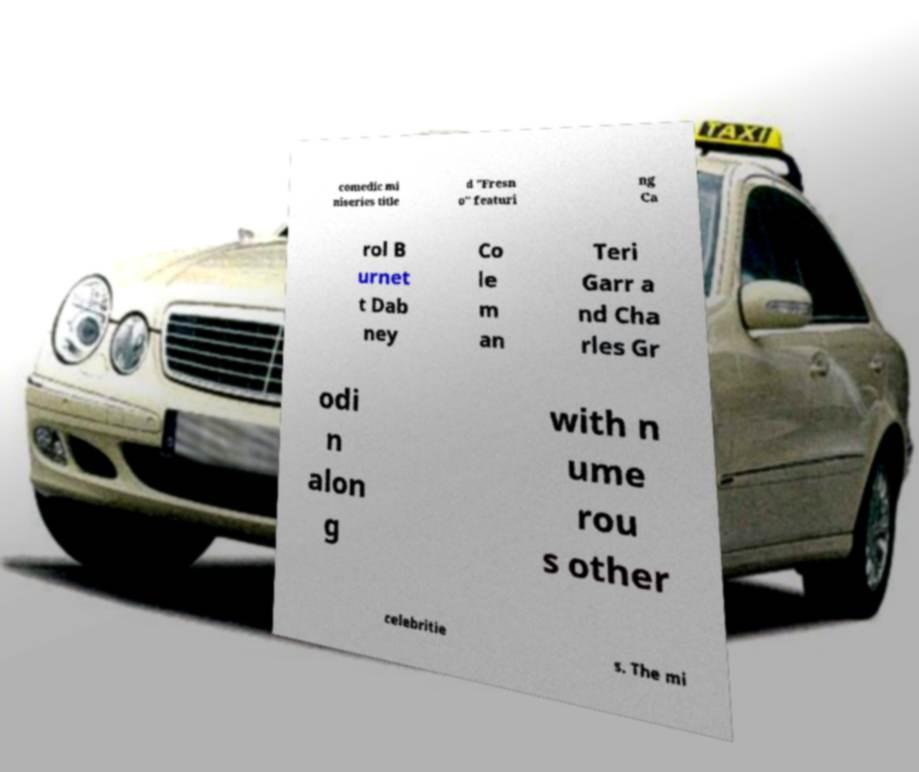Could you assist in decoding the text presented in this image and type it out clearly? comedic mi niseries title d "Fresn o" featuri ng Ca rol B urnet t Dab ney Co le m an Teri Garr a nd Cha rles Gr odi n alon g with n ume rou s other celebritie s. The mi 